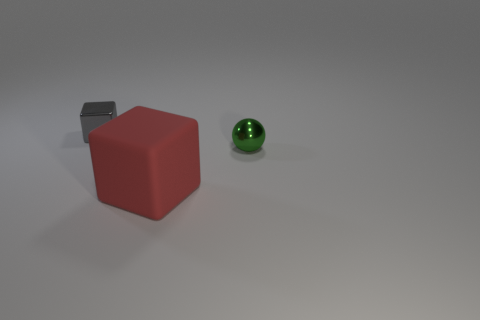Add 2 green metal balls. How many green metal balls exist? 3 Add 2 large purple rubber spheres. How many objects exist? 5 Subtract 1 green balls. How many objects are left? 2 Subtract all spheres. How many objects are left? 2 Subtract all brown cubes. Subtract all green spheres. How many cubes are left? 2 Subtract all blue blocks. How many yellow spheres are left? 0 Subtract all tiny gray cubes. Subtract all red objects. How many objects are left? 1 Add 2 tiny spheres. How many tiny spheres are left? 3 